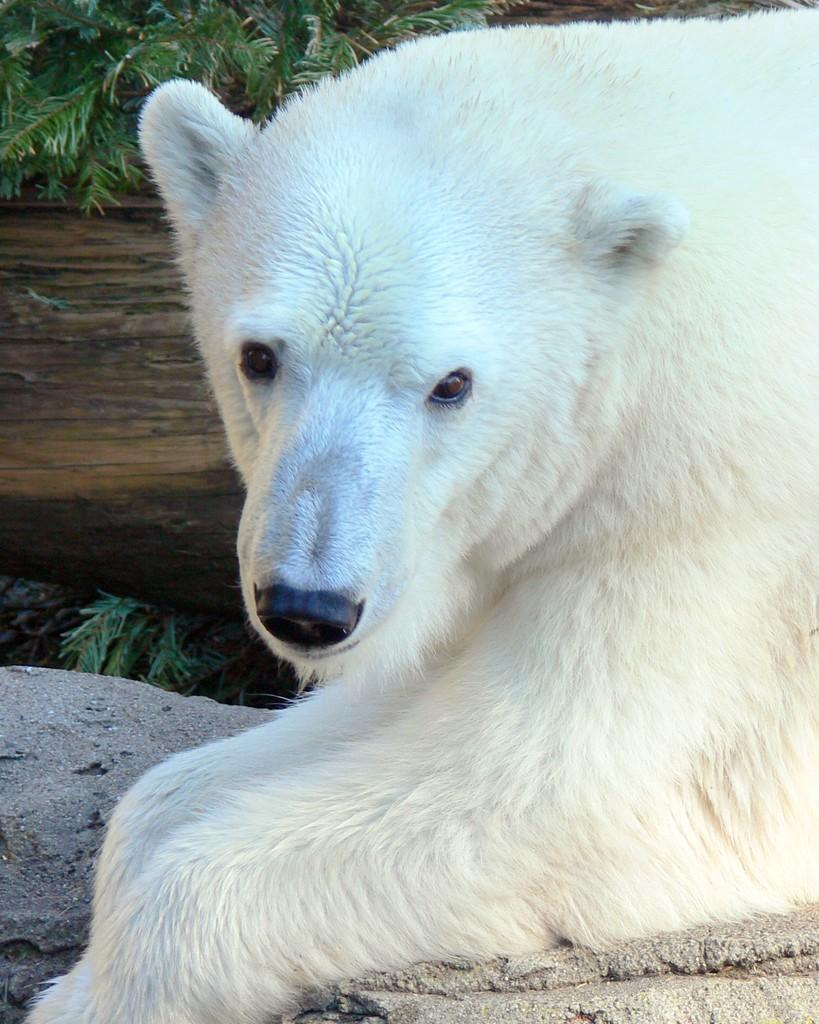What type of animal can be seen on the right side of the image? There is an animal in white color on the right side of the image. What is located on the left side of the image? There are plants on the left side of the image. What channel is the animal watching on the right side of the image? There is no indication of a television or channel in the image; it features an animal and plants. What type of meat is being prepared on the left side of the image? There is no meat or preparation of food visible in the image; it only shows plants on the left side. 